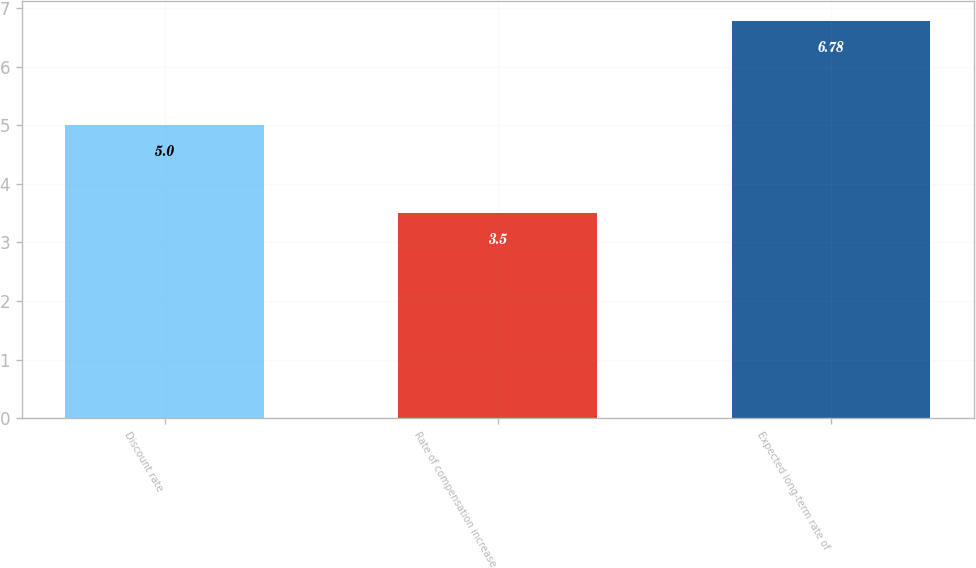<chart> <loc_0><loc_0><loc_500><loc_500><bar_chart><fcel>Discount rate<fcel>Rate of compensation increase<fcel>Expected long-term rate of<nl><fcel>5<fcel>3.5<fcel>6.78<nl></chart> 